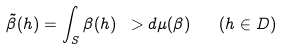Convert formula to latex. <formula><loc_0><loc_0><loc_500><loc_500>\tilde { \beta } ( h ) = \int _ { S } \beta ( h ) \ > d \mu ( \beta ) \quad ( h \in D )</formula> 